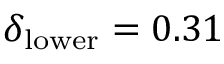Convert formula to latex. <formula><loc_0><loc_0><loc_500><loc_500>\delta _ { l o w e r } = 0 . 3 1</formula> 